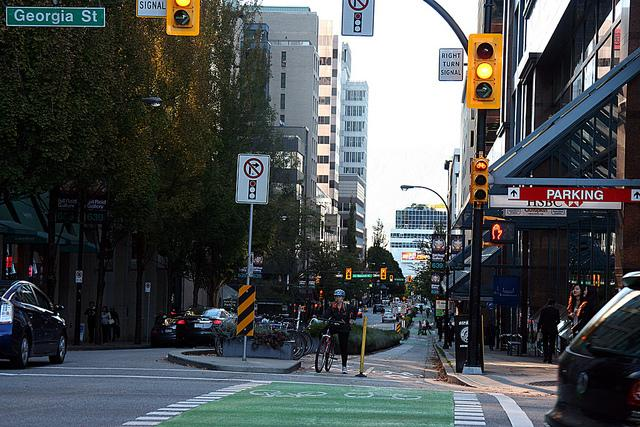What is the lane painted green for? Please explain your reasoning. bikes only. The center line is painted green for bikes to cross. 